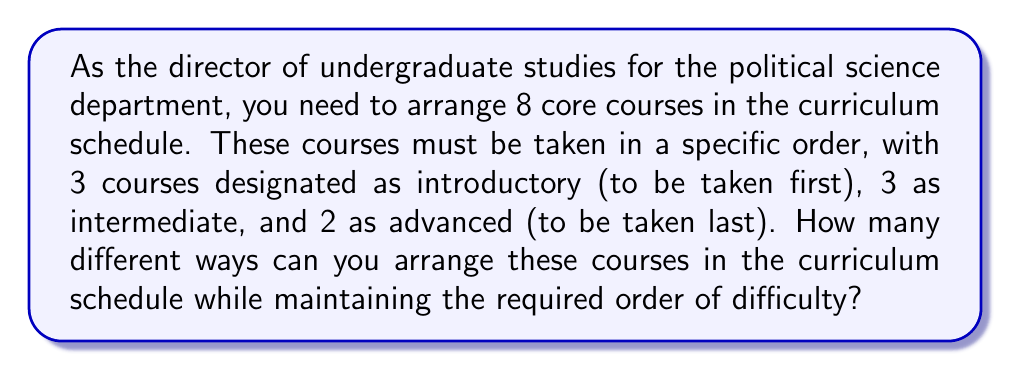What is the answer to this math problem? To solve this problem, we need to use the multiplication principle of counting and consider the arrangements within each difficulty level.

1. First, let's consider the introductory courses:
   We have 3 introductory courses that can be arranged in $3!$ ways.

2. Next, the intermediate courses:
   We have 3 intermediate courses that can be arranged in $3!$ ways.

3. Finally, the advanced courses:
   We have 2 advanced courses that can be arranged in $2!$ ways.

4. Now, we apply the multiplication principle:
   The total number of possible arrangements is the product of the number of ways to arrange each group of courses.

   Total arrangements = $3! \times 3! \times 2!$

5. Let's calculate:
   $3! = 3 \times 2 \times 1 = 6$
   $3! = 3 \times 2 \times 1 = 6$
   $2! = 2 \times 1 = 2$

   Total arrangements = $6 \times 6 \times 2 = 72$

Therefore, there are 72 different ways to arrange the political science courses in the curriculum schedule while maintaining the required order of difficulty.
Answer: 72 ways 